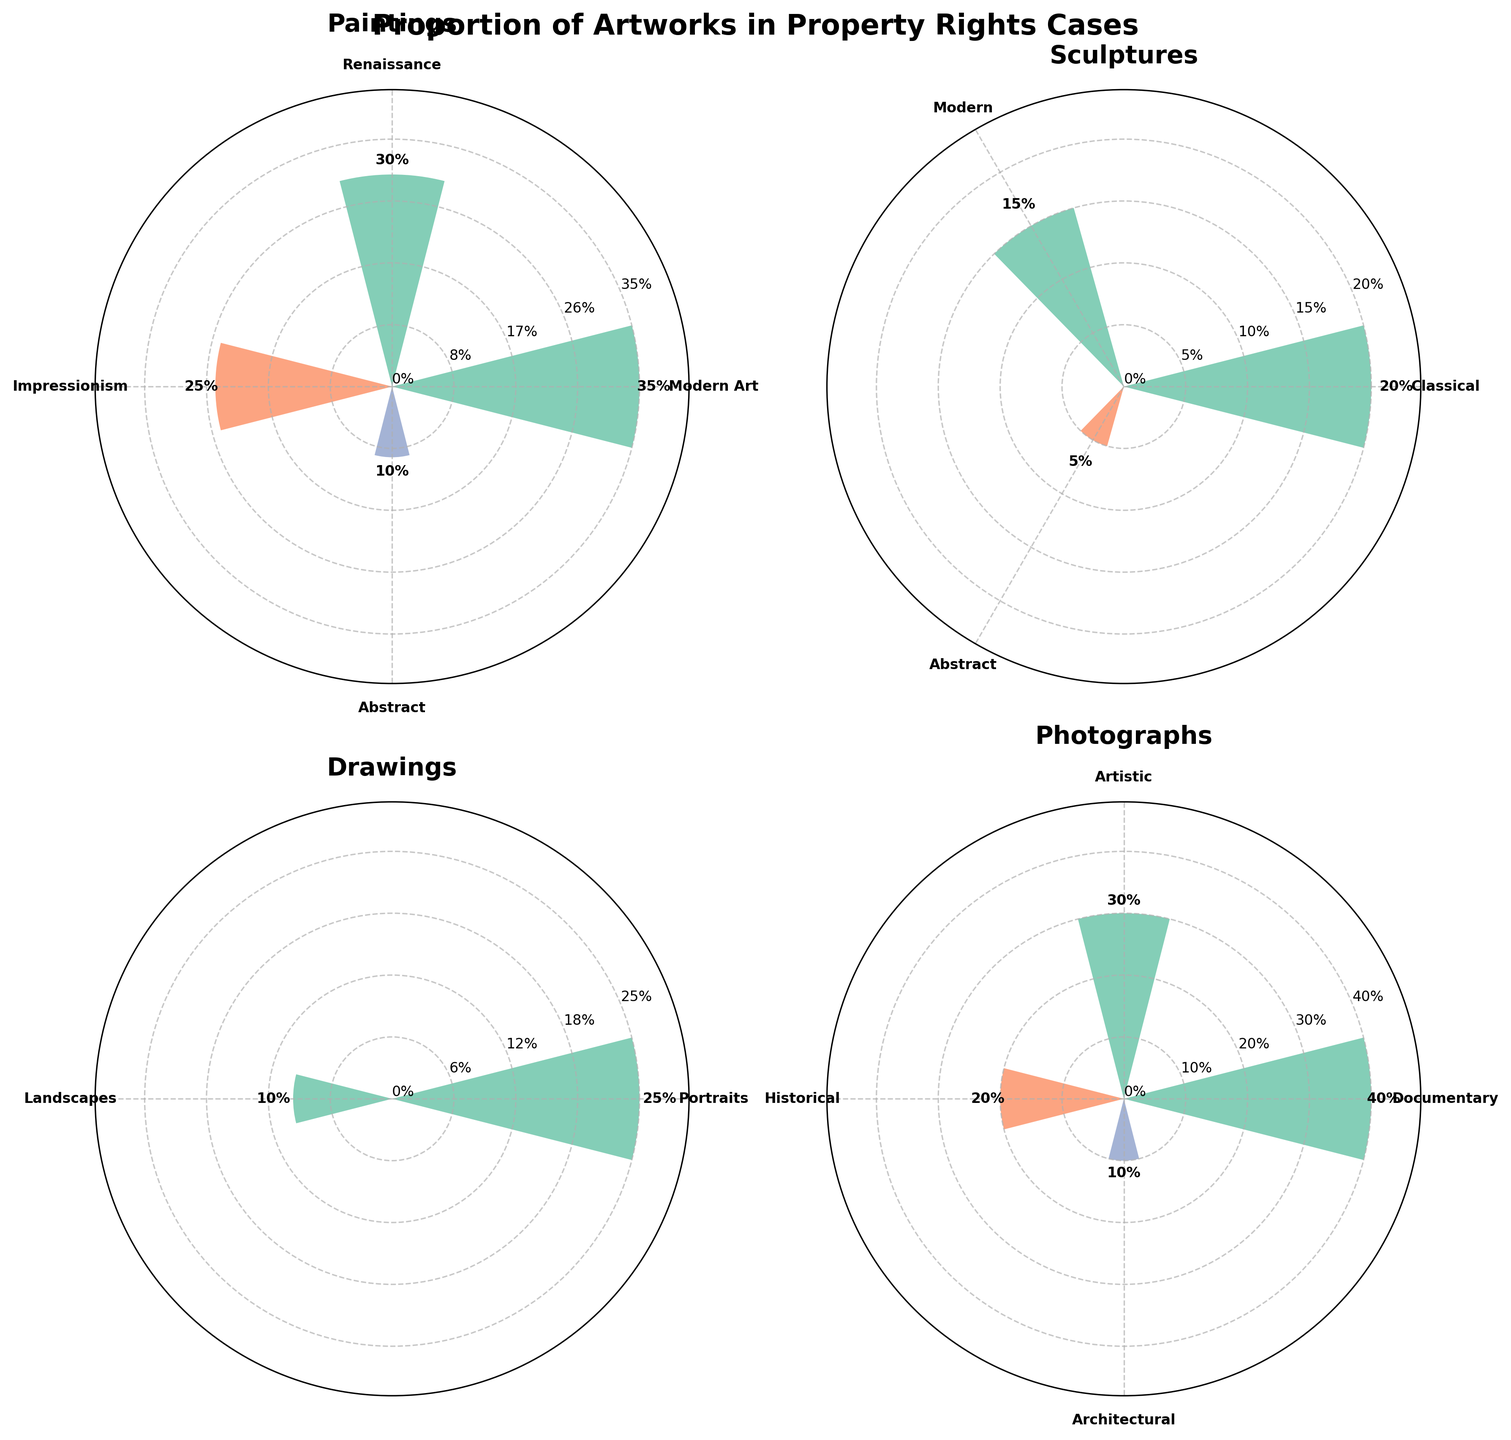Which type of artwork has the highest proportion in property rights cases? By looking at the four subplots, the 'Photograph' type has the highest value at 40% for 'Documentary'.
Answer: Photograph What is the proportion of 'Abstract' category in sculptures? In the 'Sculpture' subplot, the 'Abstract' category has a proportion of 5%.
Answer: 5% How do the proportions of 'Modern Art' in paintings and 'Modern' in sculptures compare? In the 'Painting' subplot, 'Modern Art' has a proportion of 35%. In the 'Sculpture' subplot, 'Modern' has a proportion of 15%. 'Modern Art' in paintings is higher.
Answer: Paintings What's the total proportion for all 'Photograph' categories combined? The proportions total is calculated by adding 40% (Documentary) + 30% (Artistic) + 20% (Historical) + 10% (Architectural) = 100%.
Answer: 100% Which category has the lowest proportion among all the categories plotted? The 'Sculpture' subplot shows 'Abstract' with the lowest proportion at 5%.
Answer: Abstract (Sculpture) Rank the types of artworks by their highest single-category proportion in descending order. 'Photograph' (40% for Documentary), 'Painting' (35% for Modern Art), 'Drawing' (25% for Portraits), 'Sculpture' (20% for Classical)
Answer: Photograph, Painting, Drawing, Sculpture What is the proportional difference between 'Documentary' in photographs and 'Portraits' in drawings? 'Documentary' in photographs is 40%, and 'Portraits' in drawings is 25%. The difference is 40% - 25% = 15%.
Answer: 15% In the painting category, which two sub-categories together sum to 55%? Adding 'Modern Art' (35%) and 'Renaissance' (30%) exceeds 55%, but 'Modern Art' (35%) and 'Abstract' (10%) equals 45%, similarly 'Renaissance' (30%) and 'Impressionism' (25%) equals 55%.
Answer: 'Renaissance' and 'Impressionism' Which type of artwork has the most balanced distribution among its sub-categories? Looking at the subplots, 'Photograph' has more evenly distributed proportions compared to others: 40%, 30%, 20%, and 10%.
Answer: Photograph What is the collective proportion of 'Abstract' artworks across all types? Add the proportions for 'Abstract' from paintings (10%) and sculptures (5%) since other subplots don't have 'Abstract', the total is 10% + 5% = 15%.
Answer: 15% 